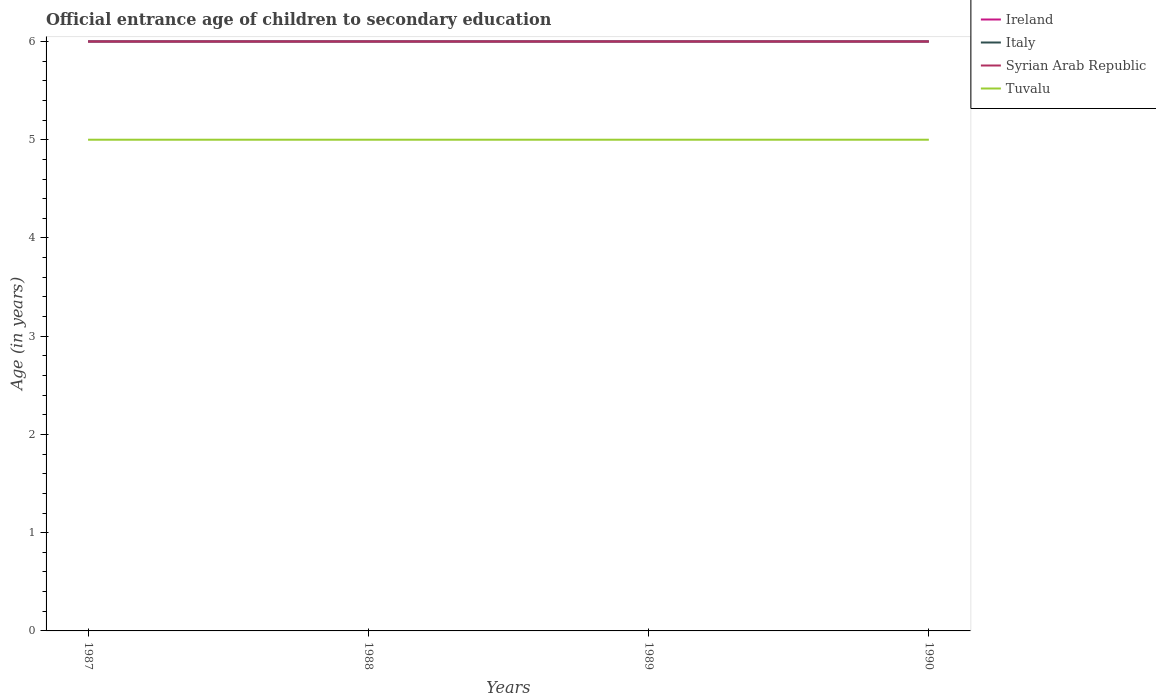How many different coloured lines are there?
Provide a short and direct response. 4. Does the line corresponding to Tuvalu intersect with the line corresponding to Syrian Arab Republic?
Keep it short and to the point. No. Is the number of lines equal to the number of legend labels?
Keep it short and to the point. Yes. Across all years, what is the maximum secondary school starting age of children in Ireland?
Offer a very short reply. 6. What is the difference between the highest and the second highest secondary school starting age of children in Tuvalu?
Provide a short and direct response. 0. How many years are there in the graph?
Give a very brief answer. 4. Does the graph contain any zero values?
Make the answer very short. No. Does the graph contain grids?
Offer a very short reply. No. How many legend labels are there?
Your response must be concise. 4. How are the legend labels stacked?
Ensure brevity in your answer.  Vertical. What is the title of the graph?
Provide a short and direct response. Official entrance age of children to secondary education. What is the label or title of the Y-axis?
Your response must be concise. Age (in years). What is the Age (in years) of Ireland in 1987?
Your answer should be very brief. 6. What is the Age (in years) of Italy in 1987?
Provide a short and direct response. 6. What is the Age (in years) in Syrian Arab Republic in 1987?
Offer a very short reply. 6. What is the Age (in years) of Italy in 1988?
Provide a short and direct response. 6. What is the Age (in years) in Syrian Arab Republic in 1988?
Your response must be concise. 6. What is the Age (in years) in Ireland in 1989?
Ensure brevity in your answer.  6. What is the Age (in years) in Italy in 1989?
Your answer should be compact. 6. What is the Age (in years) in Syrian Arab Republic in 1989?
Your response must be concise. 6. What is the Age (in years) in Tuvalu in 1989?
Offer a very short reply. 5. What is the Age (in years) of Italy in 1990?
Provide a short and direct response. 6. What is the Age (in years) of Syrian Arab Republic in 1990?
Your answer should be very brief. 6. What is the Age (in years) in Tuvalu in 1990?
Offer a very short reply. 5. Across all years, what is the maximum Age (in years) of Ireland?
Offer a very short reply. 6. Across all years, what is the maximum Age (in years) of Italy?
Give a very brief answer. 6. Across all years, what is the maximum Age (in years) in Syrian Arab Republic?
Provide a short and direct response. 6. Across all years, what is the maximum Age (in years) in Tuvalu?
Make the answer very short. 5. Across all years, what is the minimum Age (in years) of Ireland?
Your answer should be very brief. 6. What is the total Age (in years) in Italy in the graph?
Your answer should be very brief. 24. What is the total Age (in years) of Syrian Arab Republic in the graph?
Provide a short and direct response. 24. What is the difference between the Age (in years) in Ireland in 1987 and that in 1988?
Provide a short and direct response. 0. What is the difference between the Age (in years) of Syrian Arab Republic in 1987 and that in 1988?
Offer a terse response. 0. What is the difference between the Age (in years) of Ireland in 1987 and that in 1990?
Provide a succinct answer. 0. What is the difference between the Age (in years) of Italy in 1987 and that in 1990?
Offer a very short reply. 0. What is the difference between the Age (in years) of Syrian Arab Republic in 1987 and that in 1990?
Your response must be concise. 0. What is the difference between the Age (in years) in Italy in 1988 and that in 1989?
Keep it short and to the point. 0. What is the difference between the Age (in years) in Tuvalu in 1988 and that in 1989?
Offer a very short reply. 0. What is the difference between the Age (in years) of Ireland in 1988 and that in 1990?
Provide a short and direct response. 0. What is the difference between the Age (in years) of Syrian Arab Republic in 1988 and that in 1990?
Offer a terse response. 0. What is the difference between the Age (in years) in Tuvalu in 1988 and that in 1990?
Ensure brevity in your answer.  0. What is the difference between the Age (in years) of Italy in 1989 and that in 1990?
Provide a succinct answer. 0. What is the difference between the Age (in years) in Tuvalu in 1989 and that in 1990?
Keep it short and to the point. 0. What is the difference between the Age (in years) of Ireland in 1987 and the Age (in years) of Syrian Arab Republic in 1988?
Make the answer very short. 0. What is the difference between the Age (in years) of Italy in 1987 and the Age (in years) of Syrian Arab Republic in 1988?
Offer a terse response. 0. What is the difference between the Age (in years) in Italy in 1987 and the Age (in years) in Tuvalu in 1988?
Keep it short and to the point. 1. What is the difference between the Age (in years) of Syrian Arab Republic in 1987 and the Age (in years) of Tuvalu in 1988?
Make the answer very short. 1. What is the difference between the Age (in years) of Ireland in 1987 and the Age (in years) of Italy in 1989?
Ensure brevity in your answer.  0. What is the difference between the Age (in years) of Ireland in 1987 and the Age (in years) of Tuvalu in 1989?
Keep it short and to the point. 1. What is the difference between the Age (in years) of Ireland in 1987 and the Age (in years) of Syrian Arab Republic in 1990?
Your answer should be compact. 0. What is the difference between the Age (in years) in Ireland in 1987 and the Age (in years) in Tuvalu in 1990?
Make the answer very short. 1. What is the difference between the Age (in years) of Italy in 1987 and the Age (in years) of Syrian Arab Republic in 1990?
Ensure brevity in your answer.  0. What is the difference between the Age (in years) in Ireland in 1988 and the Age (in years) in Italy in 1989?
Keep it short and to the point. 0. What is the difference between the Age (in years) in Italy in 1988 and the Age (in years) in Tuvalu in 1989?
Ensure brevity in your answer.  1. What is the difference between the Age (in years) in Syrian Arab Republic in 1988 and the Age (in years) in Tuvalu in 1989?
Your answer should be very brief. 1. What is the difference between the Age (in years) of Ireland in 1988 and the Age (in years) of Syrian Arab Republic in 1990?
Provide a succinct answer. 0. What is the difference between the Age (in years) of Ireland in 1988 and the Age (in years) of Tuvalu in 1990?
Your answer should be compact. 1. What is the difference between the Age (in years) in Ireland in 1989 and the Age (in years) in Syrian Arab Republic in 1990?
Make the answer very short. 0. What is the difference between the Age (in years) in Ireland in 1989 and the Age (in years) in Tuvalu in 1990?
Offer a very short reply. 1. What is the difference between the Age (in years) in Italy in 1989 and the Age (in years) in Syrian Arab Republic in 1990?
Provide a succinct answer. 0. What is the difference between the Age (in years) in Italy in 1989 and the Age (in years) in Tuvalu in 1990?
Ensure brevity in your answer.  1. What is the difference between the Age (in years) in Syrian Arab Republic in 1989 and the Age (in years) in Tuvalu in 1990?
Your response must be concise. 1. What is the average Age (in years) of Ireland per year?
Your answer should be very brief. 6. What is the average Age (in years) of Italy per year?
Your answer should be very brief. 6. What is the average Age (in years) of Syrian Arab Republic per year?
Keep it short and to the point. 6. In the year 1987, what is the difference between the Age (in years) of Italy and Age (in years) of Tuvalu?
Your answer should be very brief. 1. In the year 1987, what is the difference between the Age (in years) of Syrian Arab Republic and Age (in years) of Tuvalu?
Keep it short and to the point. 1. In the year 1988, what is the difference between the Age (in years) in Ireland and Age (in years) in Italy?
Make the answer very short. 0. In the year 1988, what is the difference between the Age (in years) of Ireland and Age (in years) of Syrian Arab Republic?
Give a very brief answer. 0. In the year 1988, what is the difference between the Age (in years) in Syrian Arab Republic and Age (in years) in Tuvalu?
Provide a short and direct response. 1. In the year 1989, what is the difference between the Age (in years) in Ireland and Age (in years) in Italy?
Your answer should be very brief. 0. In the year 1989, what is the difference between the Age (in years) in Ireland and Age (in years) in Tuvalu?
Your answer should be very brief. 1. In the year 1990, what is the difference between the Age (in years) of Ireland and Age (in years) of Italy?
Provide a short and direct response. 0. In the year 1990, what is the difference between the Age (in years) in Ireland and Age (in years) in Syrian Arab Republic?
Your answer should be very brief. 0. In the year 1990, what is the difference between the Age (in years) of Ireland and Age (in years) of Tuvalu?
Provide a short and direct response. 1. In the year 1990, what is the difference between the Age (in years) of Italy and Age (in years) of Tuvalu?
Provide a succinct answer. 1. What is the ratio of the Age (in years) of Ireland in 1987 to that in 1988?
Ensure brevity in your answer.  1. What is the ratio of the Age (in years) in Tuvalu in 1987 to that in 1988?
Ensure brevity in your answer.  1. What is the ratio of the Age (in years) in Italy in 1987 to that in 1989?
Offer a terse response. 1. What is the ratio of the Age (in years) in Syrian Arab Republic in 1987 to that in 1989?
Offer a terse response. 1. What is the ratio of the Age (in years) of Ireland in 1987 to that in 1990?
Your answer should be very brief. 1. What is the ratio of the Age (in years) in Syrian Arab Republic in 1987 to that in 1990?
Your response must be concise. 1. What is the ratio of the Age (in years) in Tuvalu in 1987 to that in 1990?
Keep it short and to the point. 1. What is the ratio of the Age (in years) in Ireland in 1988 to that in 1989?
Your response must be concise. 1. What is the ratio of the Age (in years) of Italy in 1988 to that in 1990?
Your response must be concise. 1. What is the ratio of the Age (in years) in Tuvalu in 1988 to that in 1990?
Provide a short and direct response. 1. What is the ratio of the Age (in years) of Syrian Arab Republic in 1989 to that in 1990?
Your response must be concise. 1. What is the ratio of the Age (in years) in Tuvalu in 1989 to that in 1990?
Ensure brevity in your answer.  1. What is the difference between the highest and the second highest Age (in years) of Ireland?
Offer a terse response. 0. What is the difference between the highest and the second highest Age (in years) in Italy?
Keep it short and to the point. 0. What is the difference between the highest and the lowest Age (in years) of Syrian Arab Republic?
Keep it short and to the point. 0. 